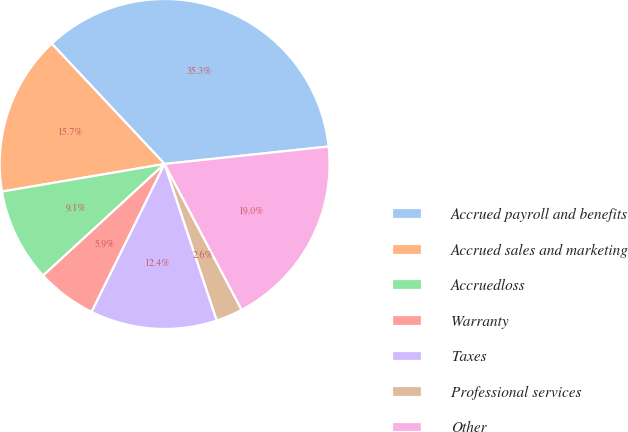Convert chart to OTSL. <chart><loc_0><loc_0><loc_500><loc_500><pie_chart><fcel>Accrued payroll and benefits<fcel>Accrued sales and marketing<fcel>Accruedloss<fcel>Warranty<fcel>Taxes<fcel>Professional services<fcel>Other<nl><fcel>35.31%<fcel>15.69%<fcel>9.15%<fcel>5.88%<fcel>12.42%<fcel>2.61%<fcel>18.96%<nl></chart> 